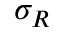<formula> <loc_0><loc_0><loc_500><loc_500>\sigma _ { R }</formula> 